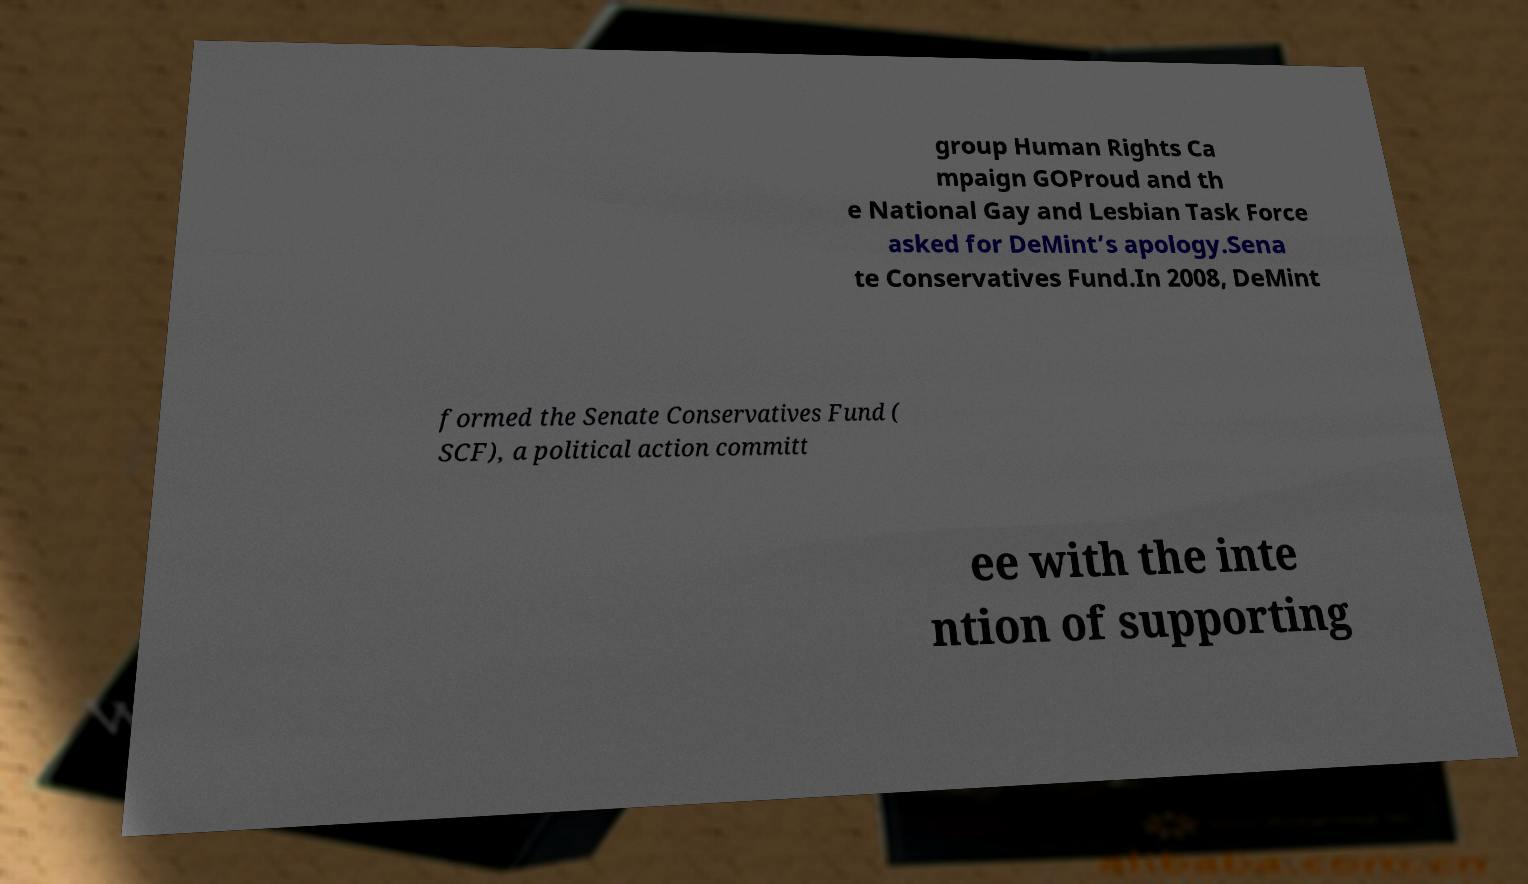What messages or text are displayed in this image? I need them in a readable, typed format. group Human Rights Ca mpaign GOProud and th e National Gay and Lesbian Task Force asked for DeMint’s apology.Sena te Conservatives Fund.In 2008, DeMint formed the Senate Conservatives Fund ( SCF), a political action committ ee with the inte ntion of supporting 